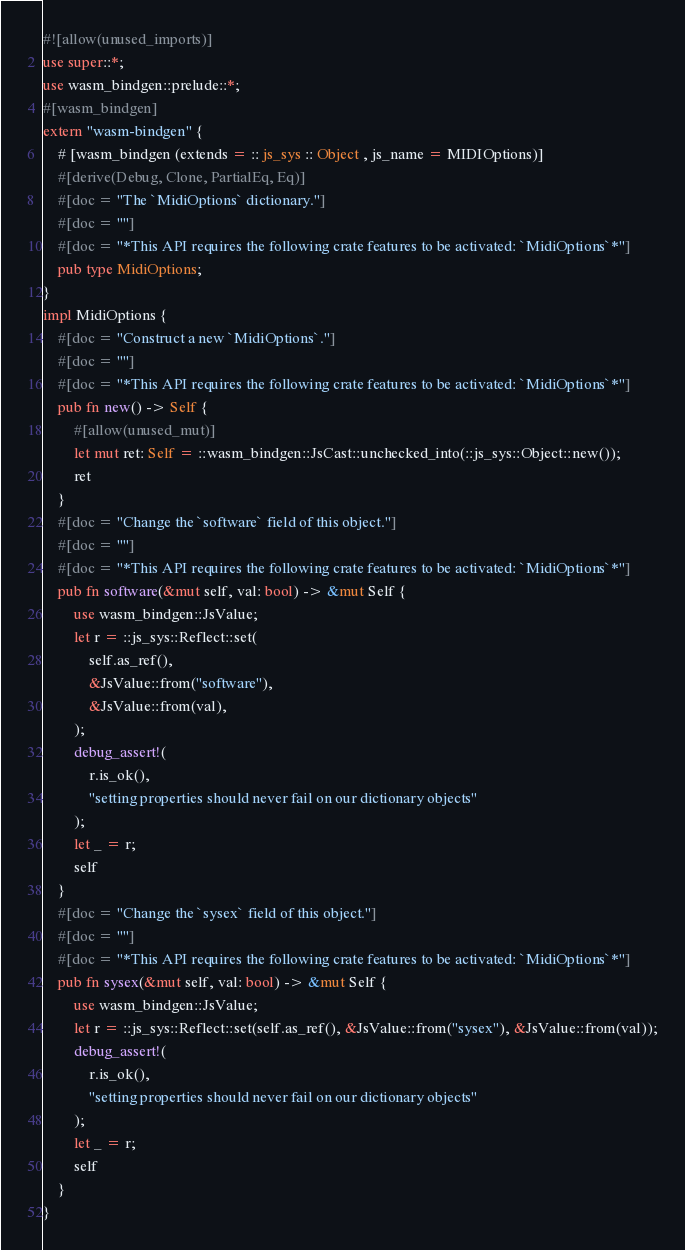Convert code to text. <code><loc_0><loc_0><loc_500><loc_500><_Rust_>#![allow(unused_imports)]
use super::*;
use wasm_bindgen::prelude::*;
#[wasm_bindgen]
extern "wasm-bindgen" {
    # [wasm_bindgen (extends = :: js_sys :: Object , js_name = MIDIOptions)]
    #[derive(Debug, Clone, PartialEq, Eq)]
    #[doc = "The `MidiOptions` dictionary."]
    #[doc = ""]
    #[doc = "*This API requires the following crate features to be activated: `MidiOptions`*"]
    pub type MidiOptions;
}
impl MidiOptions {
    #[doc = "Construct a new `MidiOptions`."]
    #[doc = ""]
    #[doc = "*This API requires the following crate features to be activated: `MidiOptions`*"]
    pub fn new() -> Self {
        #[allow(unused_mut)]
        let mut ret: Self = ::wasm_bindgen::JsCast::unchecked_into(::js_sys::Object::new());
        ret
    }
    #[doc = "Change the `software` field of this object."]
    #[doc = ""]
    #[doc = "*This API requires the following crate features to be activated: `MidiOptions`*"]
    pub fn software(&mut self, val: bool) -> &mut Self {
        use wasm_bindgen::JsValue;
        let r = ::js_sys::Reflect::set(
            self.as_ref(),
            &JsValue::from("software"),
            &JsValue::from(val),
        );
        debug_assert!(
            r.is_ok(),
            "setting properties should never fail on our dictionary objects"
        );
        let _ = r;
        self
    }
    #[doc = "Change the `sysex` field of this object."]
    #[doc = ""]
    #[doc = "*This API requires the following crate features to be activated: `MidiOptions`*"]
    pub fn sysex(&mut self, val: bool) -> &mut Self {
        use wasm_bindgen::JsValue;
        let r = ::js_sys::Reflect::set(self.as_ref(), &JsValue::from("sysex"), &JsValue::from(val));
        debug_assert!(
            r.is_ok(),
            "setting properties should never fail on our dictionary objects"
        );
        let _ = r;
        self
    }
}
</code> 